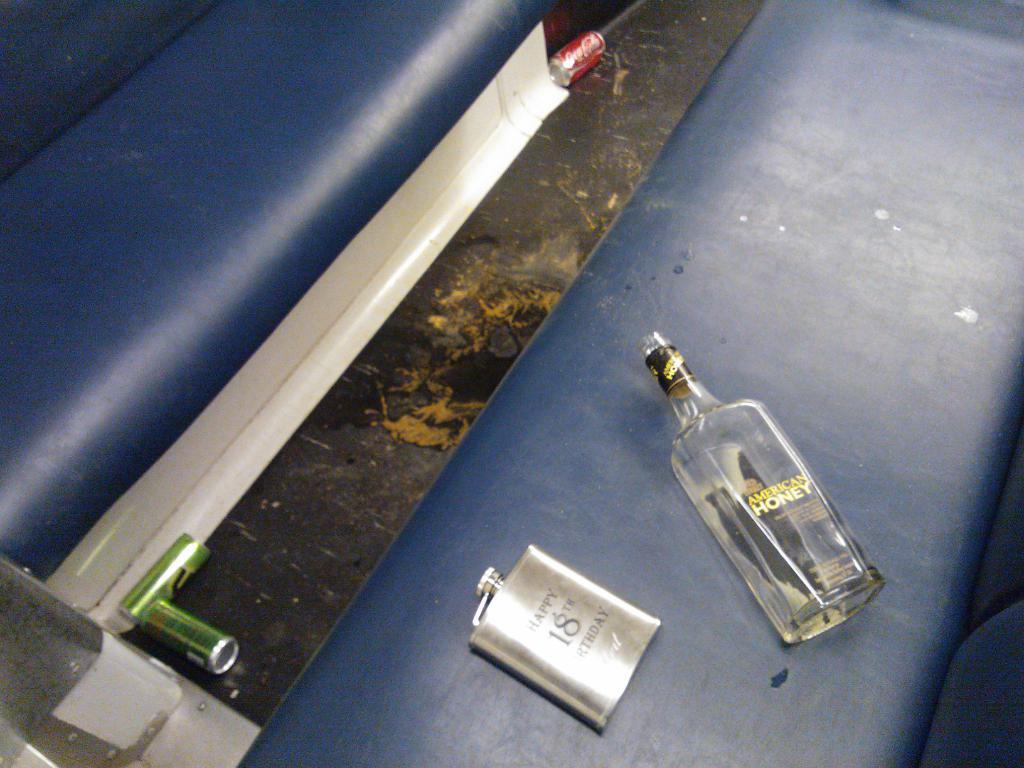What type of beverage container is present in the image? There is a wine bottle in the image. What other type of beverage container can is visible in the image? There is a Coca Cola can on the sofa and another Coca Cola can on or near another bed. What type of furniture is present in the image? The image contains a sofa and another bed. How many airports are visible in the image? There are no airports present in the image. What is the grip of the wine bottle like in the image? The grip of the wine bottle cannot be determined from the image, as it is a static object. 